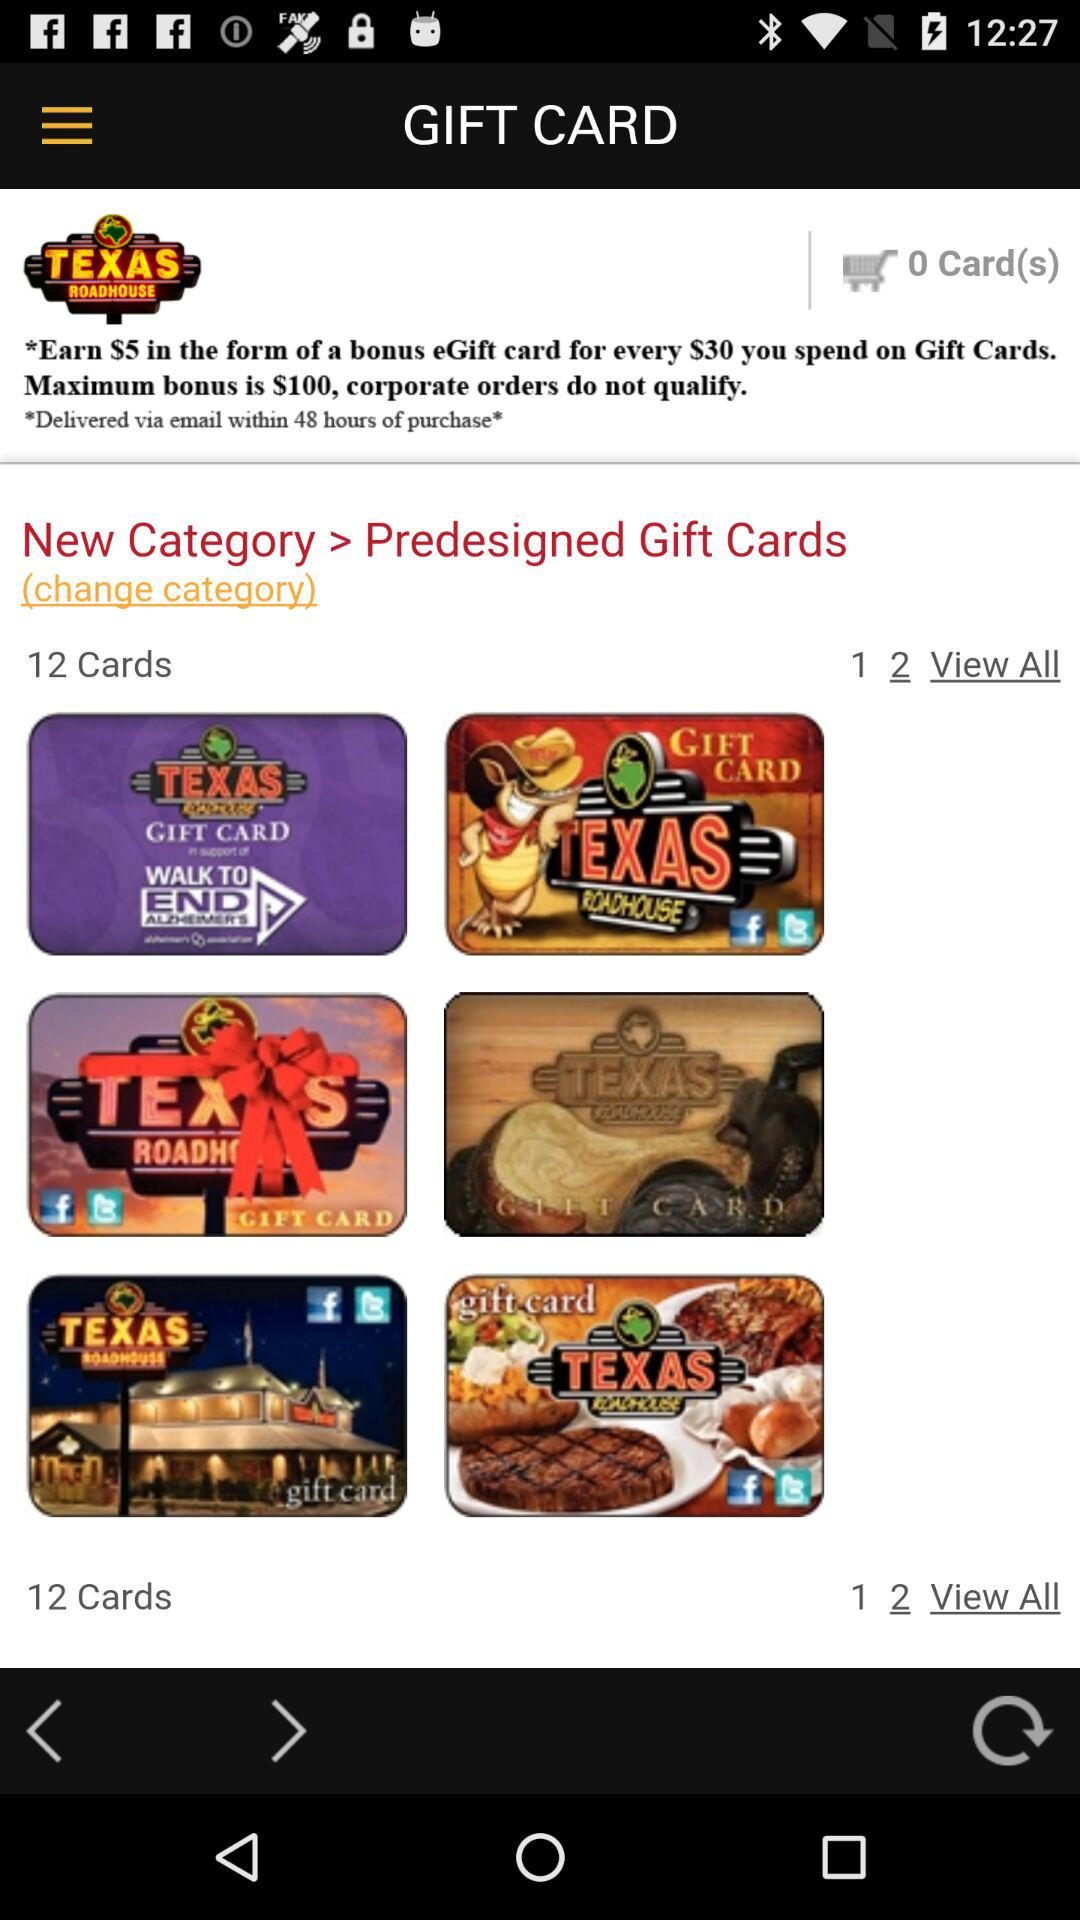How many cards are available in the current category?
Answer the question using a single word or phrase. 12 